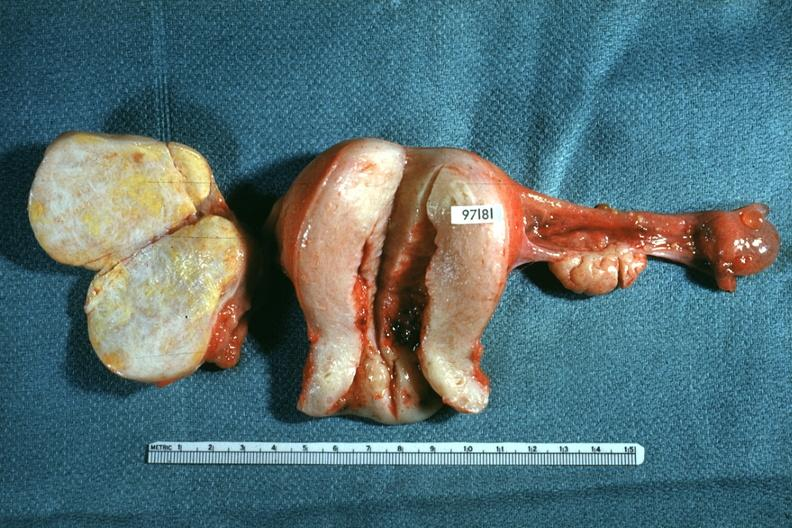s female reproductive present?
Answer the question using a single word or phrase. Yes 